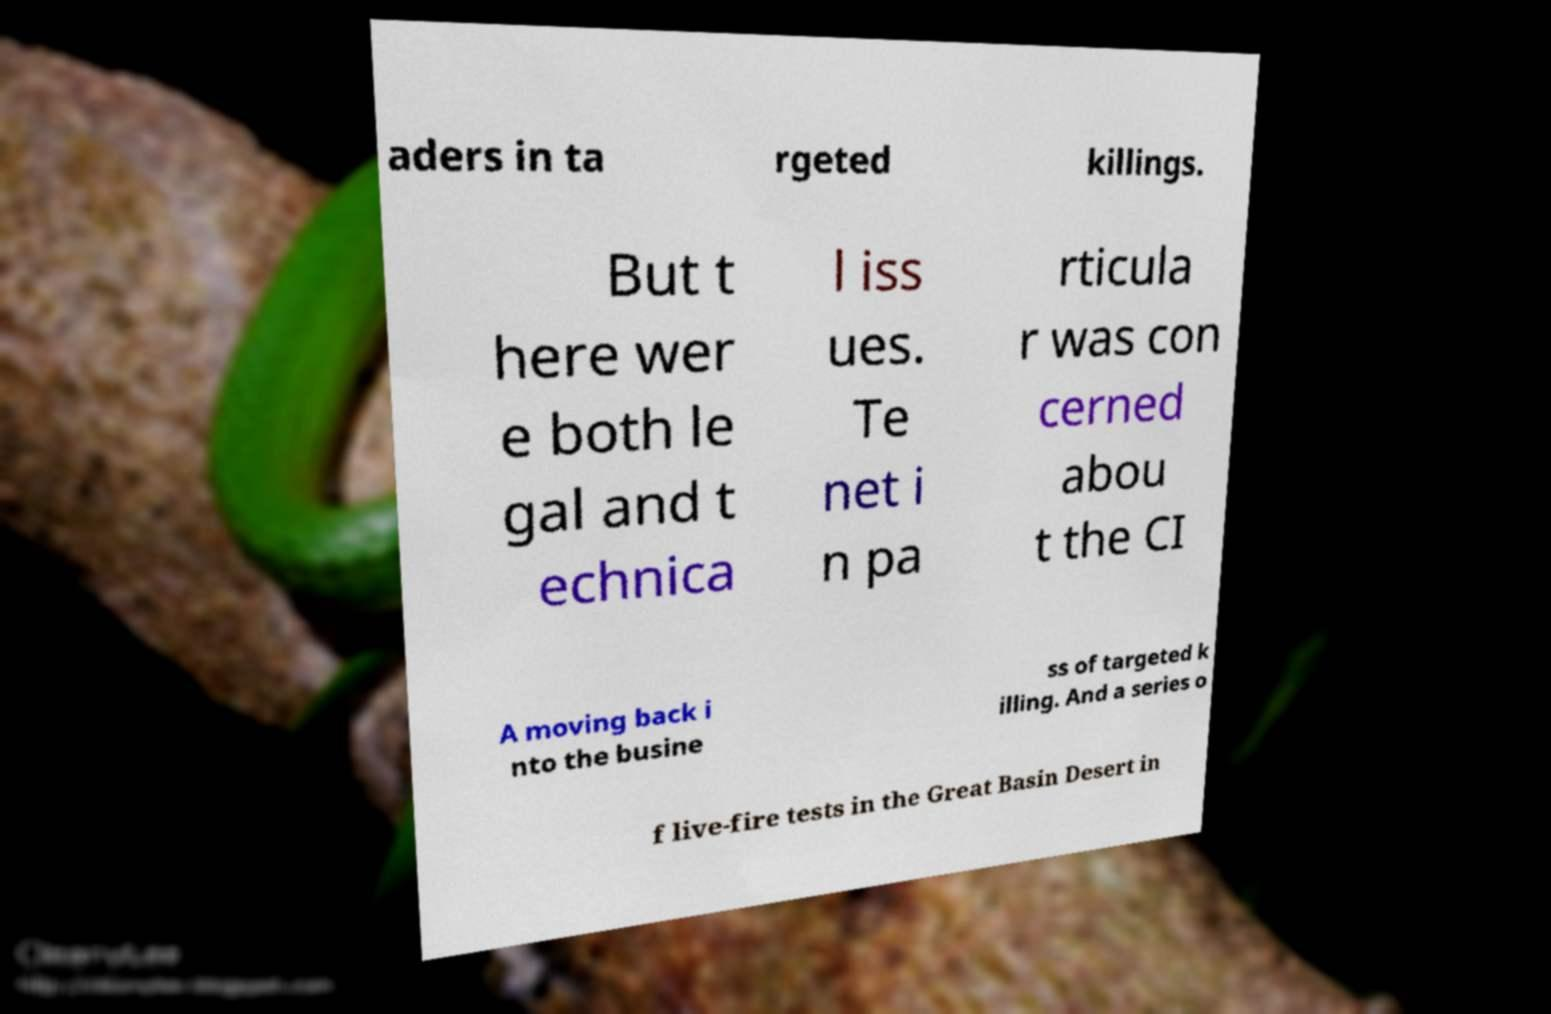Can you read and provide the text displayed in the image?This photo seems to have some interesting text. Can you extract and type it out for me? aders in ta rgeted killings. But t here wer e both le gal and t echnica l iss ues. Te net i n pa rticula r was con cerned abou t the CI A moving back i nto the busine ss of targeted k illing. And a series o f live-fire tests in the Great Basin Desert in 